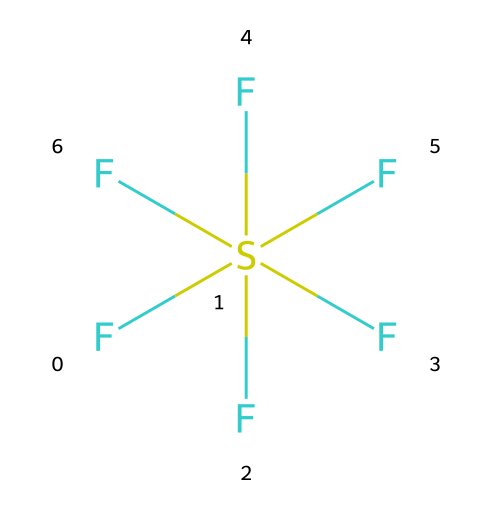What is the chemical formula of this compound? The compound's SMILES representation shows it consists of one sulfur atom and six fluorine atoms, which corresponds to the formula SF6.
Answer: SF6 How many fluorine atoms are present in this molecule? The SMILES representation indicates "F[S](F)(F)(F)(F)F", which shows there are six fluorine atoms attached to one sulfur atom.
Answer: 6 What type of bond is primarily present in this structure? Analyzing the structure, the bond between sulfur and each fluorine is a covalent bond, characteristic of nonmetals sharing electrons.
Answer: covalent Is this chemical classified as a greenhouse gas? Sulfur hexafluoride (SF6) is known for its potent greenhouse gas properties due to its ability to trap heat in the atmosphere.
Answer: yes What is the primary use of sulfur hexafluoride in industry? This compound is widely used in electrical equipment as an insulator, as its excellent electrical insulating properties make it very effective.
Answer: insulator Why is sulfur hexafluoride considered hazardous? SF6 is considered hazardous due to its greenhouse gas potential, where even small amounts can significantly contribute to global warming.
Answer: greenhouse gas How does the electronegativity of fluorine affect this compound? The high electronegativity of fluorine causes strong polar covalent bonds with sulfur, thus contributing to the stability and low reactivity of SF6.
Answer: stability 